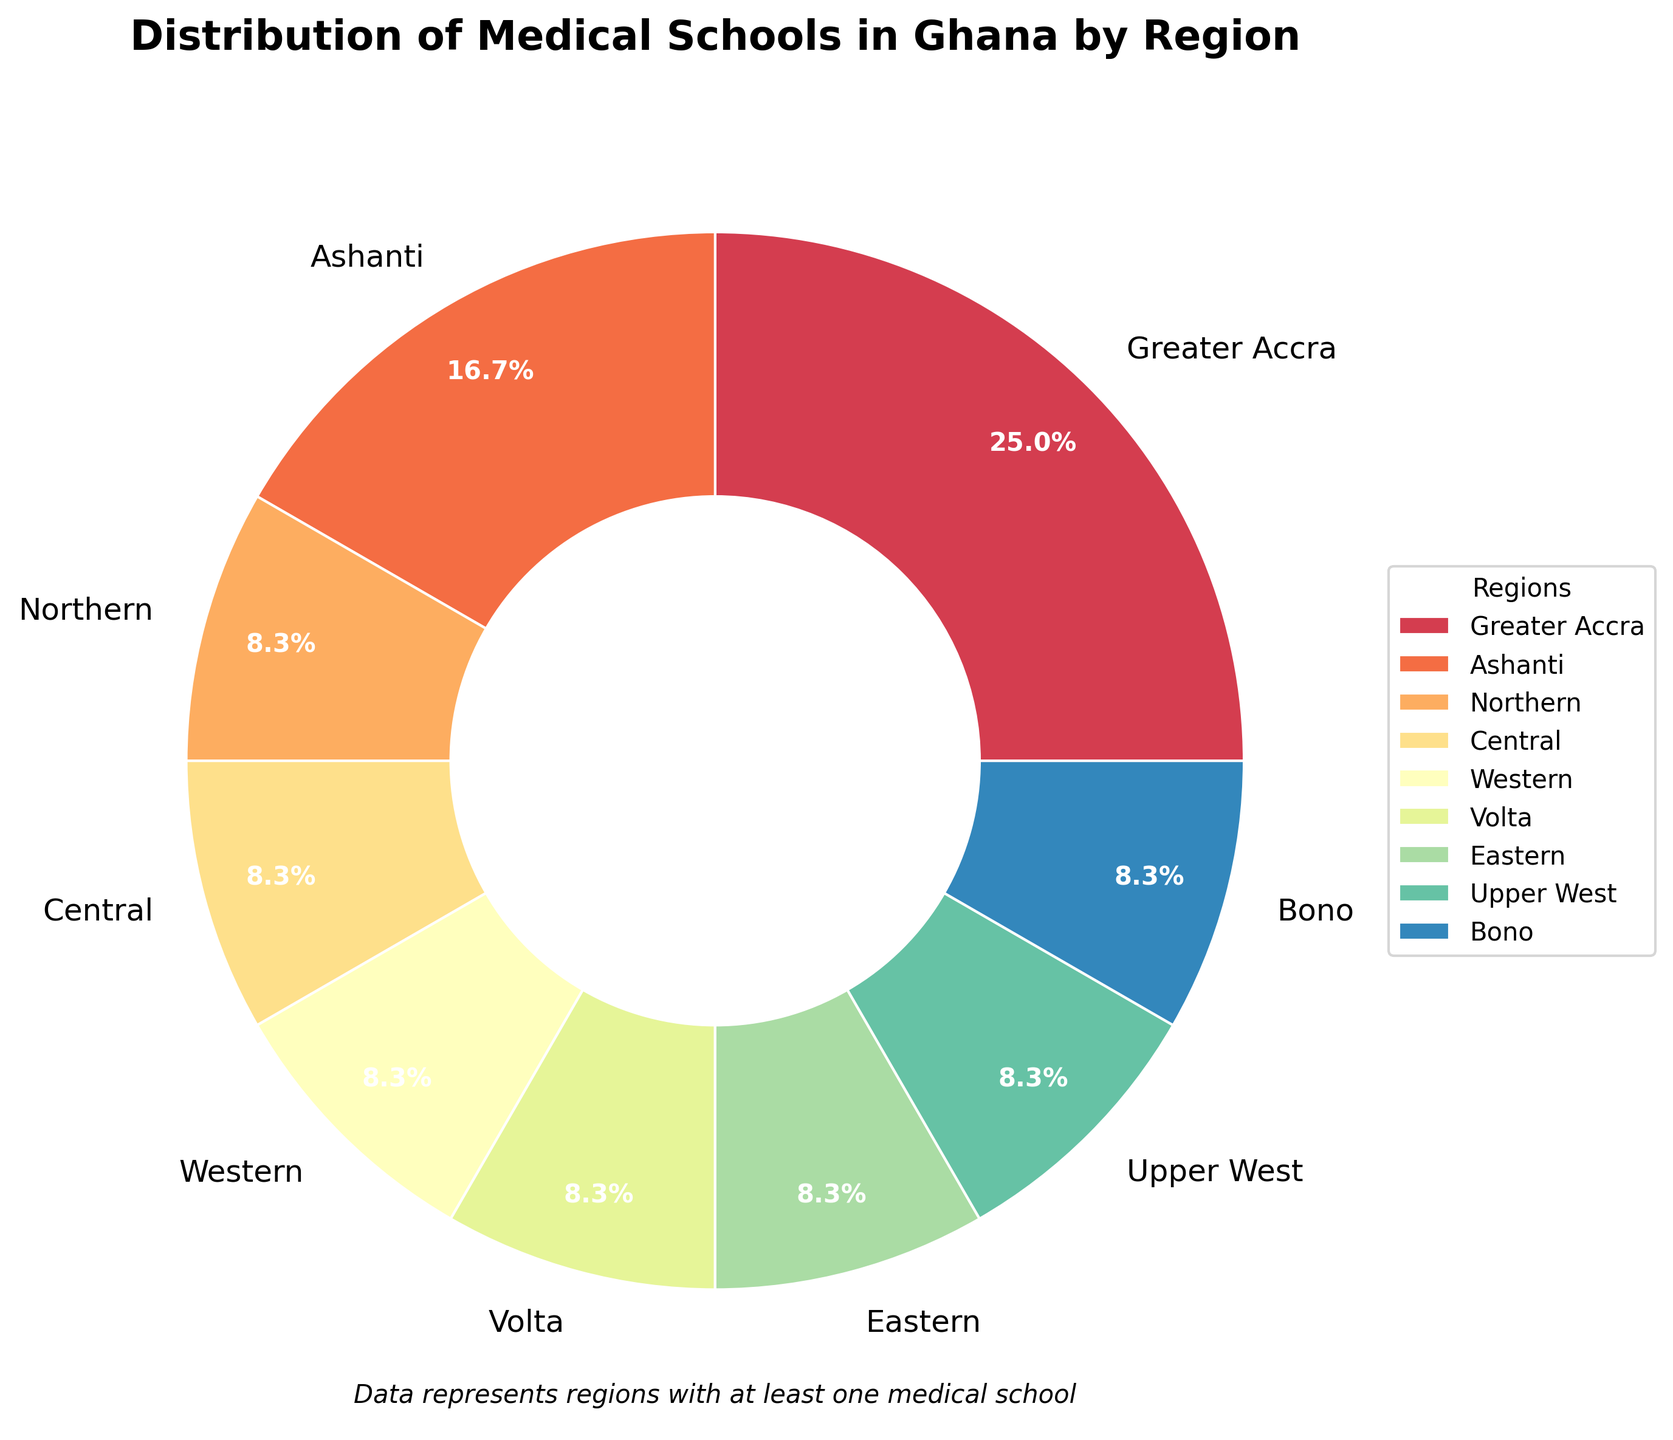What is the total number of medical schools represented in the pie chart? To find the total number of medical schools, sum the number of schools in all regions depicted in the pie chart: 3 (Greater Accra) + 2 (Ashanti) + 1 (Northern) + 1 (Central) + 1 (Western) + 1 (Volta) + 1 (Eastern) + 1 (Upper West) + 1 (Bono) = 11.
Answer: 11 Which region has the highest number of medical schools? From the pie chart, the segment labeled "Greater Accra" is the largest, indicating Greater Accra has the highest number of medical schools, which is 3.
Answer: Greater Accra How does the number of medical schools in Greater Accra compare to Ashanti? The pie chart shows that Greater Accra has 3 medical schools, while Ashanti has 2 medical schools. Thus, Greater Accra has one more medical school than Ashanti.
Answer: Greater Accra has one more school What percentage of the total medical schools are located in the Greater Accra region? From the pie chart, the Greater Accra region is labeled with "27.3%", indicating it has 27.3% of the total medical schools.
Answer: 27.3% How many regions have only one medical school? By examining the chart, we can identify regions with a single medical school by their labels: Northern, Central, Western, Volta, Eastern, Upper West, and Bono. Counting these, there are 7 such regions.
Answer: 7 What is the average number of medical schools per region according to the chart? The chart displays regions with at least one school, totaling 9 regions. The sum of schools is 11, so the average is calculated as 11 divided by 9, which equals roughly 1.22.
Answer: 1.22 By how many medical schools does Greater Accra surpass the total of Upper West and Bono combined? Greater Accra has 3 medical schools, while Upper West and Bono have 1 each. Summing Upper West and Bono, we get 1 + 1 = 2. Thus, Greater Accra surpasses by 3 - 2 = 1.
Answer: 1 Which region has a similar number of medical schools to the Central region? Both Central and the regions Northern, Western, Volta, Eastern, Upper West, and Bono each have 1 medical school, indicating they have similar numbers.
Answer: Northern, Western, Volta, Eastern, Upper West, Bono What fraction of the total medical schools do the Ashanti and Western regions together represent? Ashanti has 2 schools and Western has 1, summing up to 3. The total number of schools is 11, so the fraction is 3/11.
Answer: 3/11 